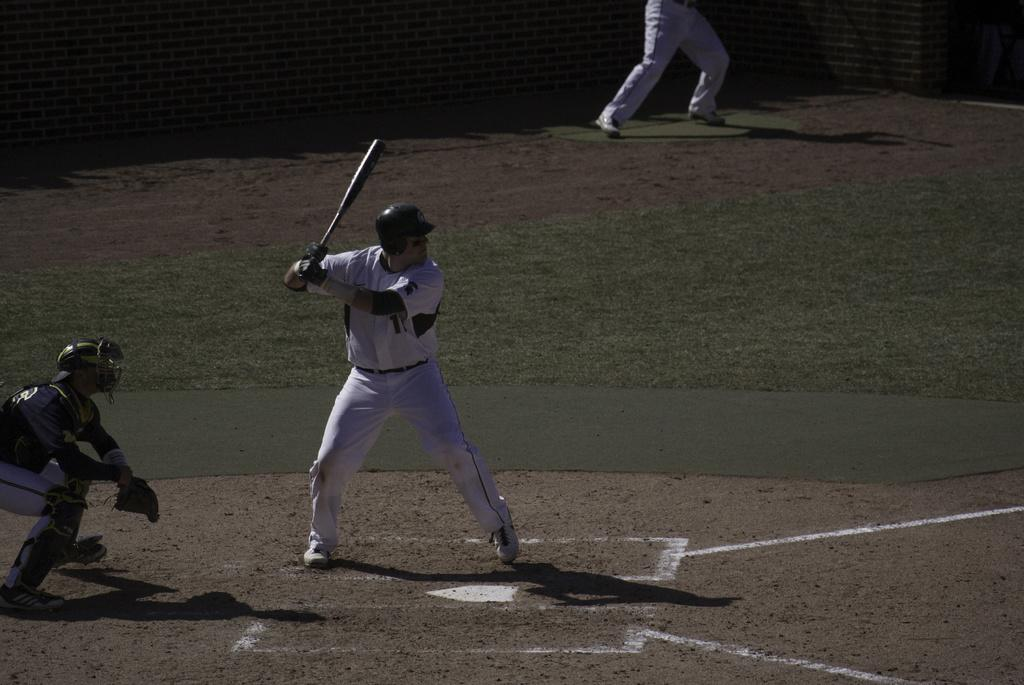How many people are in the image? There are three persons in the image. What are the positions of the persons in the image? The persons are on the ground. What is one person holding in the image? One person is holding a bat. What protective gear is one person wearing in the image? One person is wearing a helmet. What can be seen in the background of the image? There is a wall in the background of the image. What type of breakfast is being prepared in the image? There is no indication of breakfast or any food preparation in the image. How many pancakes are visible in the image? There are no pancakes present in the image. 